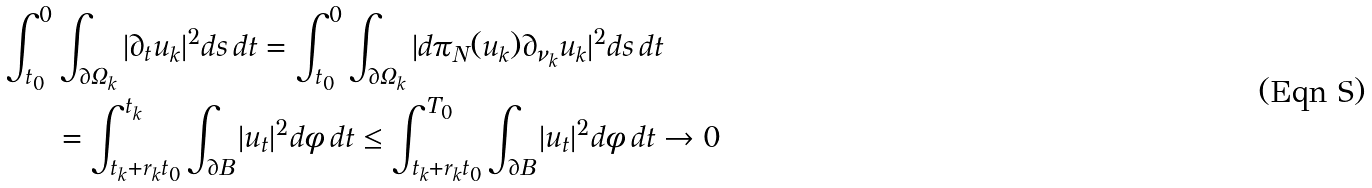Convert formula to latex. <formula><loc_0><loc_0><loc_500><loc_500>\int _ { t _ { 0 } } ^ { 0 } & \int _ { \partial \Omega _ { k } } | \partial _ { t } u _ { k } | ^ { 2 } d s \, d t = \int _ { t _ { 0 } } ^ { 0 } \int _ { \partial \Omega _ { k } } | d \pi _ { N } ( u _ { k } ) \partial _ { \nu _ { k } } u _ { k } | ^ { 2 } d s \, d t \\ & = \int _ { t _ { k } + r _ { k } t _ { 0 } } ^ { t _ { k } } \int _ { \partial B } | u _ { t } | ^ { 2 } d \phi \, d t \leq \int _ { t _ { k } + r _ { k } t _ { 0 } } ^ { T _ { 0 } } \int _ { \partial B } | u _ { t } | ^ { 2 } d \phi \, d t \to 0</formula> 